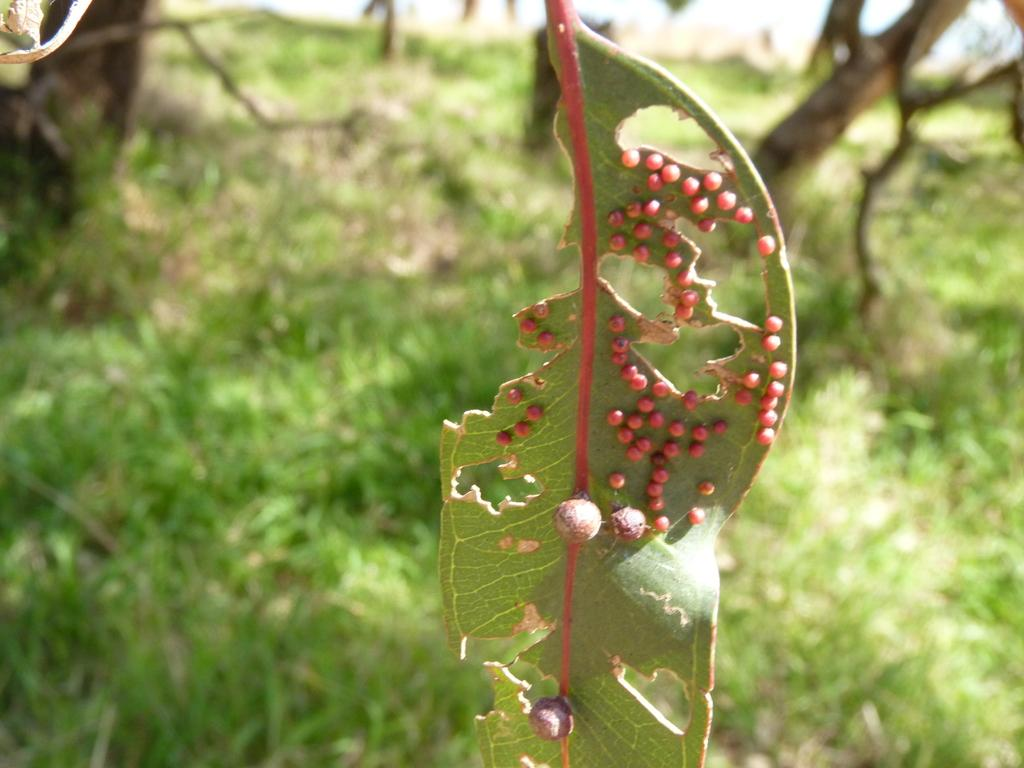What is the main subject of the image? The main subject of the image is a leaf with buds. What can be seen in the background of the image? There are trees and grass visible in the background of the image. How many jellyfish can be seen swimming in the image? There are no jellyfish present in the image; it features a leaf with buds and a background of trees and grass. 